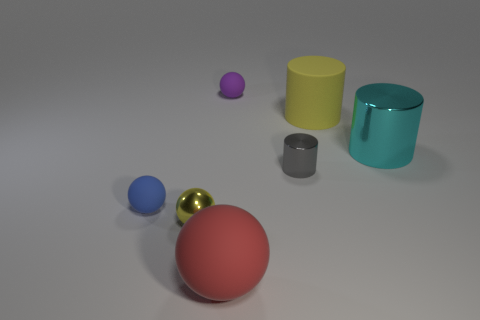Subtract all large shiny cylinders. How many cylinders are left? 2 Subtract all yellow cylinders. How many cylinders are left? 2 Subtract all spheres. How many objects are left? 3 Subtract 2 cylinders. How many cylinders are left? 1 Subtract all blue cylinders. How many purple spheres are left? 1 Subtract all yellow objects. Subtract all big yellow matte things. How many objects are left? 4 Add 3 cylinders. How many cylinders are left? 6 Add 6 red objects. How many red objects exist? 7 Add 1 big metal cylinders. How many objects exist? 8 Subtract 1 blue spheres. How many objects are left? 6 